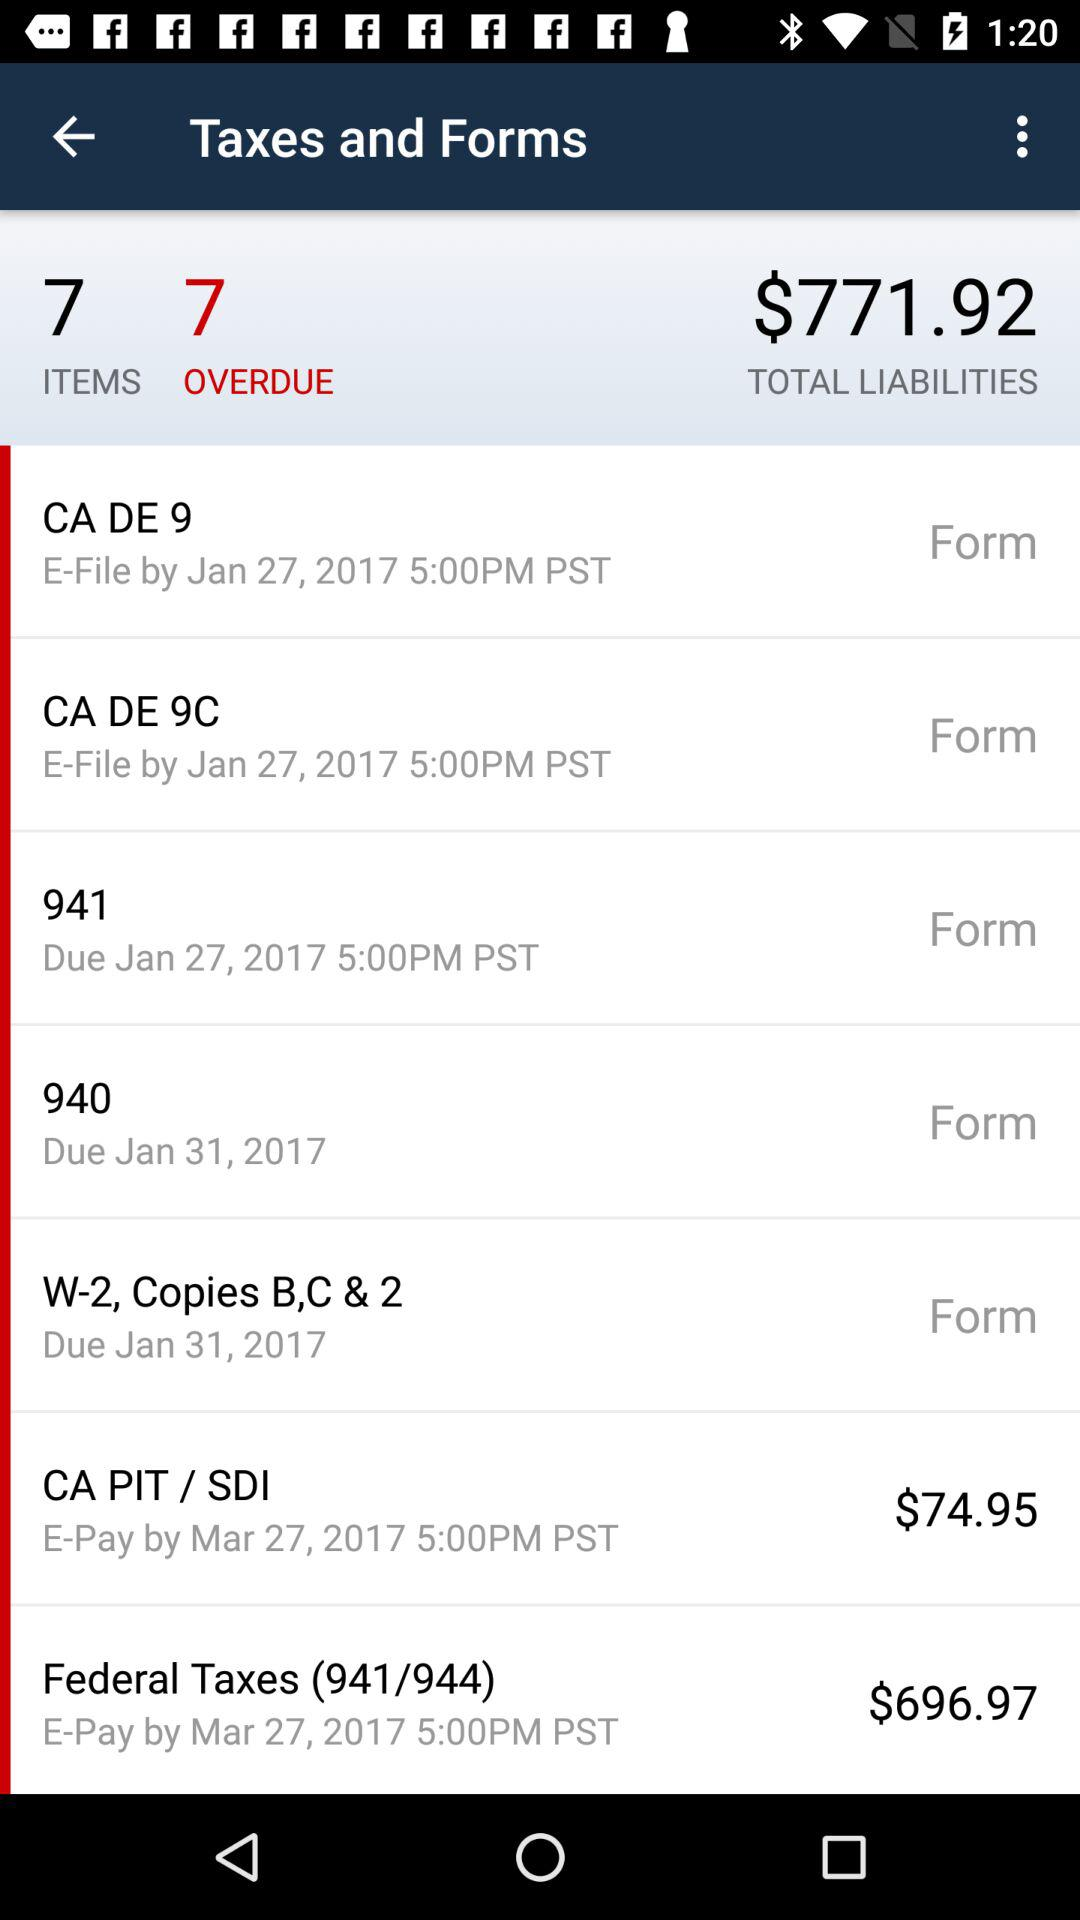How many items are there? There are 7 items. 